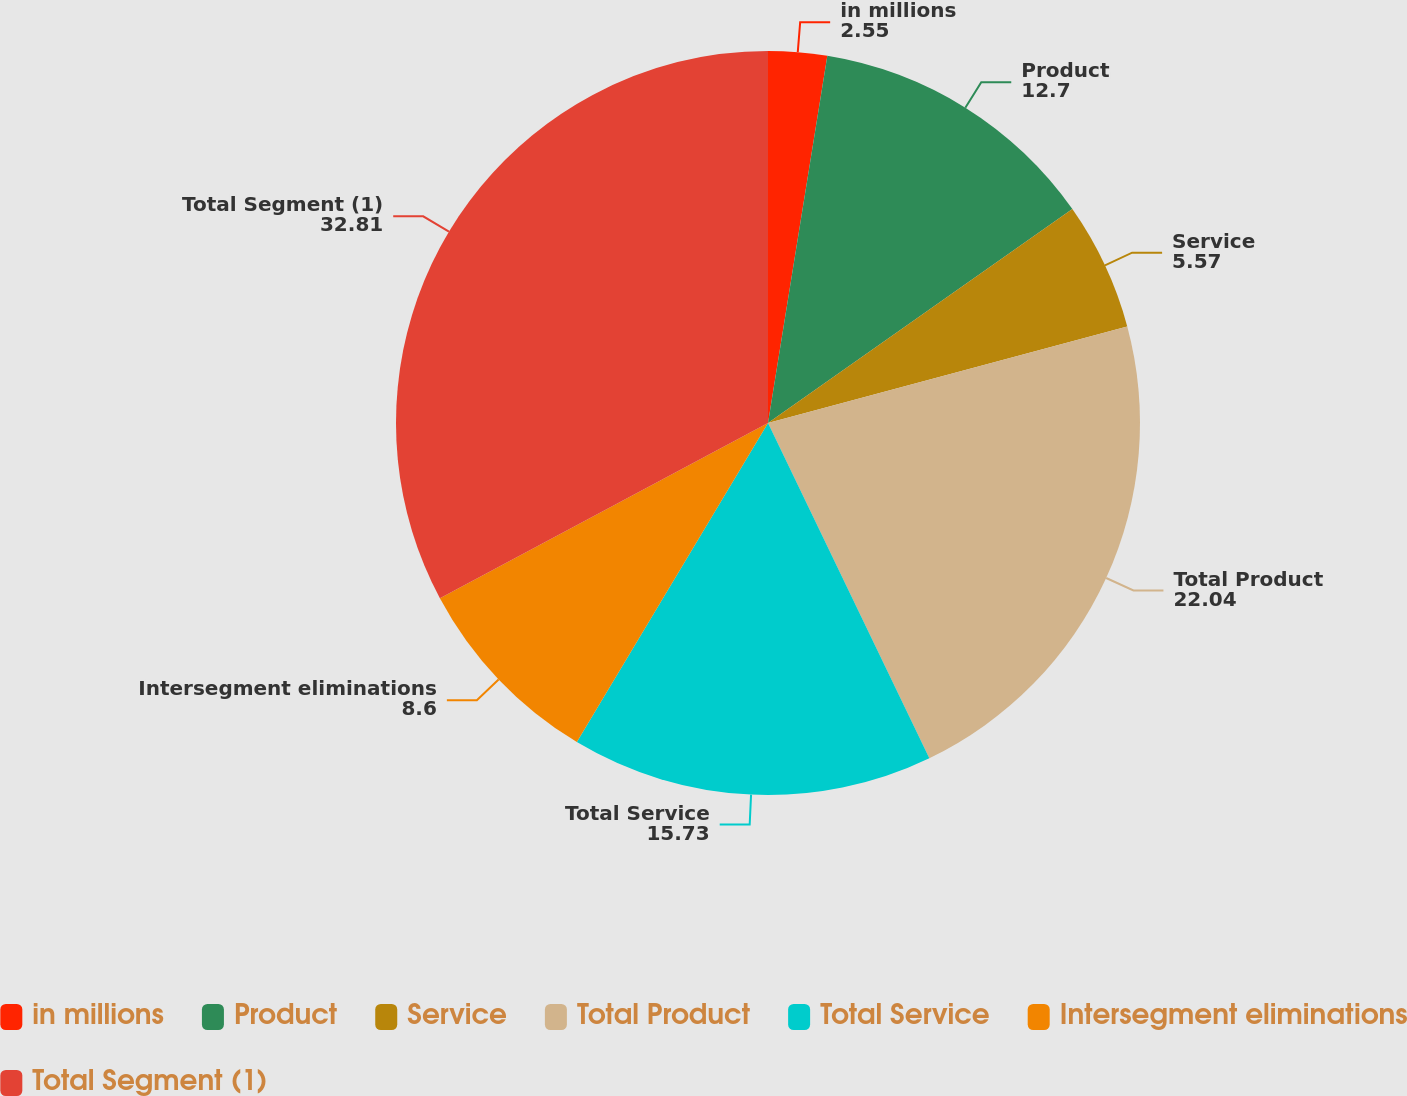Convert chart to OTSL. <chart><loc_0><loc_0><loc_500><loc_500><pie_chart><fcel>in millions<fcel>Product<fcel>Service<fcel>Total Product<fcel>Total Service<fcel>Intersegment eliminations<fcel>Total Segment (1)<nl><fcel>2.55%<fcel>12.7%<fcel>5.57%<fcel>22.04%<fcel>15.73%<fcel>8.6%<fcel>32.81%<nl></chart> 